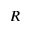Convert formula to latex. <formula><loc_0><loc_0><loc_500><loc_500>R</formula> 